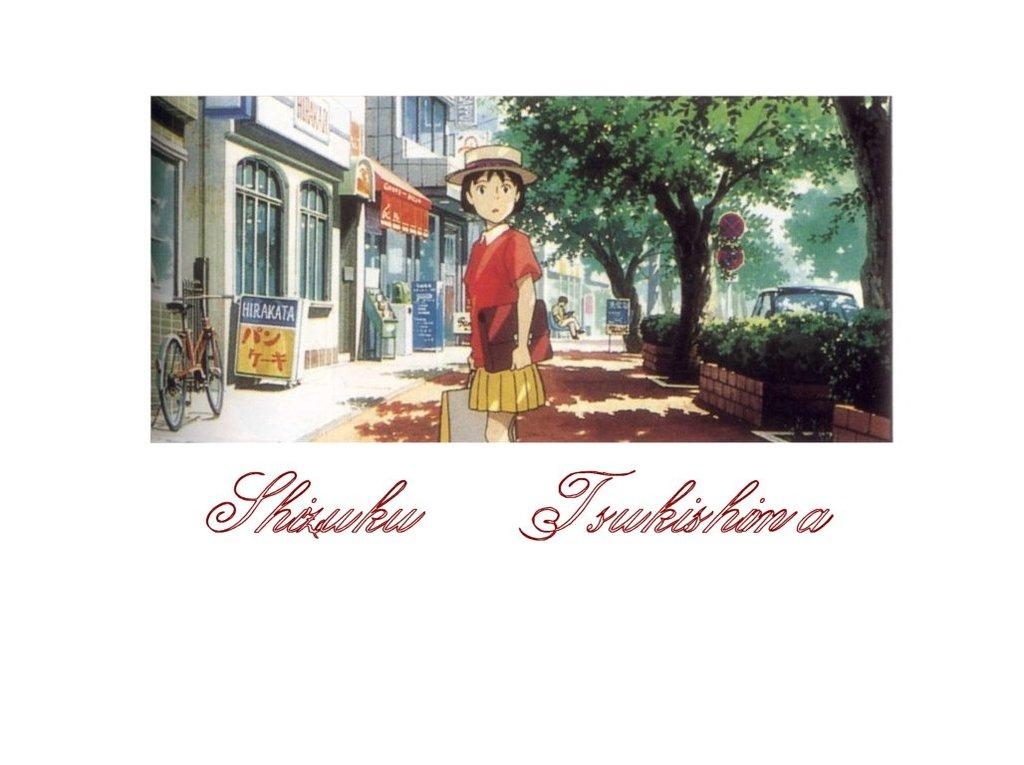What is depicted on the poster in the image? There is a poster of an anime in the image. What can be seen written on the poster? There is something written on the poster. What is the girl in the image doing? The girl is standing on a road in the image. What type of vegetation is visible on either side of the road? Trees are visible on either side of the road. What type of structures are present on either side of the road? Houses are present on either side of the road. Can you tell me how many rats are running across the girl's head in the image? There are no rats present in the image, and the girl's head is not mentioned in the provided facts. 